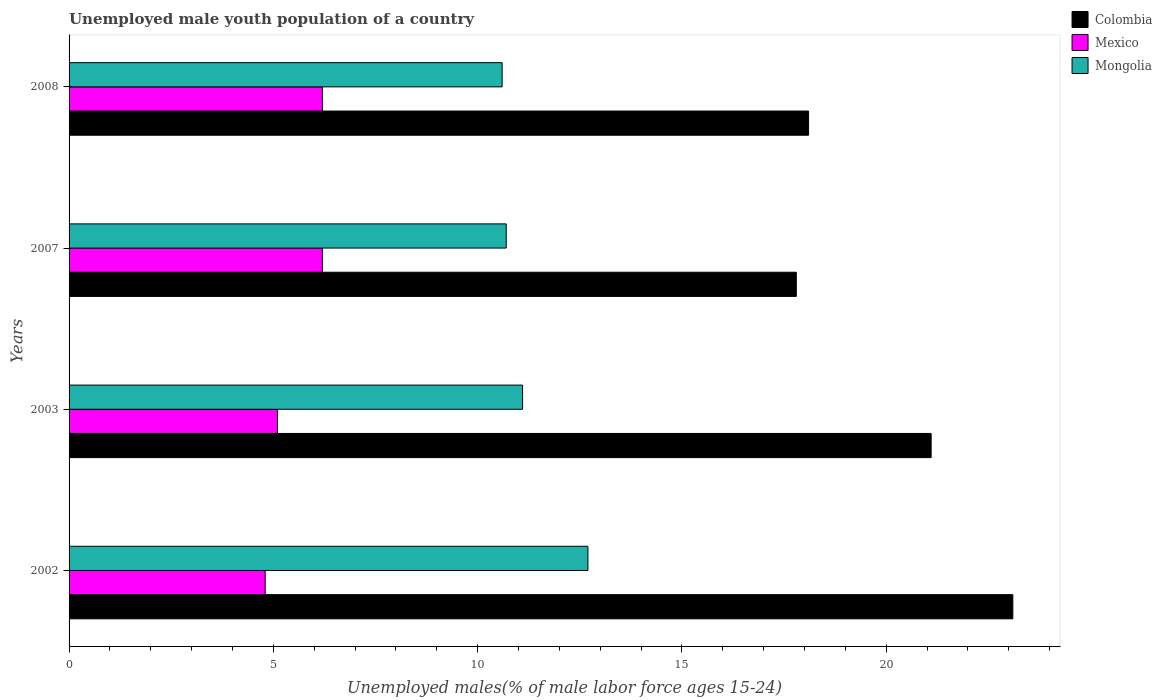Are the number of bars on each tick of the Y-axis equal?
Offer a terse response. Yes. How many bars are there on the 1st tick from the bottom?
Provide a succinct answer. 3. What is the percentage of unemployed male youth population in Mexico in 2008?
Offer a terse response. 6.2. Across all years, what is the maximum percentage of unemployed male youth population in Colombia?
Make the answer very short. 23.1. Across all years, what is the minimum percentage of unemployed male youth population in Colombia?
Ensure brevity in your answer.  17.8. In which year was the percentage of unemployed male youth population in Mongolia maximum?
Ensure brevity in your answer.  2002. In which year was the percentage of unemployed male youth population in Mongolia minimum?
Provide a succinct answer. 2008. What is the total percentage of unemployed male youth population in Mexico in the graph?
Provide a short and direct response. 22.3. What is the difference between the percentage of unemployed male youth population in Colombia in 2007 and that in 2008?
Provide a short and direct response. -0.3. What is the difference between the percentage of unemployed male youth population in Mexico in 2008 and the percentage of unemployed male youth population in Colombia in 2007?
Offer a terse response. -11.6. What is the average percentage of unemployed male youth population in Mongolia per year?
Give a very brief answer. 11.28. In the year 2007, what is the difference between the percentage of unemployed male youth population in Mexico and percentage of unemployed male youth population in Mongolia?
Give a very brief answer. -4.5. In how many years, is the percentage of unemployed male youth population in Mongolia greater than 9 %?
Give a very brief answer. 4. What is the ratio of the percentage of unemployed male youth population in Colombia in 2003 to that in 2008?
Keep it short and to the point. 1.17. Is the percentage of unemployed male youth population in Mexico in 2003 less than that in 2008?
Give a very brief answer. Yes. Is the difference between the percentage of unemployed male youth population in Mexico in 2002 and 2007 greater than the difference between the percentage of unemployed male youth population in Mongolia in 2002 and 2007?
Make the answer very short. No. What is the difference between the highest and the second highest percentage of unemployed male youth population in Colombia?
Offer a terse response. 2. What is the difference between the highest and the lowest percentage of unemployed male youth population in Mongolia?
Provide a succinct answer. 2.1. What does the 1st bar from the top in 2002 represents?
Give a very brief answer. Mongolia. What does the 3rd bar from the bottom in 2008 represents?
Your answer should be very brief. Mongolia. Is it the case that in every year, the sum of the percentage of unemployed male youth population in Mongolia and percentage of unemployed male youth population in Mexico is greater than the percentage of unemployed male youth population in Colombia?
Your answer should be very brief. No. How many bars are there?
Provide a short and direct response. 12. Does the graph contain any zero values?
Your answer should be very brief. No. Does the graph contain grids?
Ensure brevity in your answer.  No. How many legend labels are there?
Ensure brevity in your answer.  3. How are the legend labels stacked?
Offer a very short reply. Vertical. What is the title of the graph?
Your answer should be very brief. Unemployed male youth population of a country. Does "Brunei Darussalam" appear as one of the legend labels in the graph?
Give a very brief answer. No. What is the label or title of the X-axis?
Your answer should be compact. Unemployed males(% of male labor force ages 15-24). What is the label or title of the Y-axis?
Your response must be concise. Years. What is the Unemployed males(% of male labor force ages 15-24) in Colombia in 2002?
Offer a terse response. 23.1. What is the Unemployed males(% of male labor force ages 15-24) of Mexico in 2002?
Provide a succinct answer. 4.8. What is the Unemployed males(% of male labor force ages 15-24) in Mongolia in 2002?
Your response must be concise. 12.7. What is the Unemployed males(% of male labor force ages 15-24) in Colombia in 2003?
Your answer should be compact. 21.1. What is the Unemployed males(% of male labor force ages 15-24) in Mexico in 2003?
Make the answer very short. 5.1. What is the Unemployed males(% of male labor force ages 15-24) in Mongolia in 2003?
Provide a succinct answer. 11.1. What is the Unemployed males(% of male labor force ages 15-24) in Colombia in 2007?
Your response must be concise. 17.8. What is the Unemployed males(% of male labor force ages 15-24) of Mexico in 2007?
Provide a short and direct response. 6.2. What is the Unemployed males(% of male labor force ages 15-24) of Mongolia in 2007?
Offer a very short reply. 10.7. What is the Unemployed males(% of male labor force ages 15-24) in Colombia in 2008?
Keep it short and to the point. 18.1. What is the Unemployed males(% of male labor force ages 15-24) of Mexico in 2008?
Keep it short and to the point. 6.2. What is the Unemployed males(% of male labor force ages 15-24) of Mongolia in 2008?
Keep it short and to the point. 10.6. Across all years, what is the maximum Unemployed males(% of male labor force ages 15-24) of Colombia?
Give a very brief answer. 23.1. Across all years, what is the maximum Unemployed males(% of male labor force ages 15-24) of Mexico?
Offer a terse response. 6.2. Across all years, what is the maximum Unemployed males(% of male labor force ages 15-24) in Mongolia?
Provide a short and direct response. 12.7. Across all years, what is the minimum Unemployed males(% of male labor force ages 15-24) of Colombia?
Give a very brief answer. 17.8. Across all years, what is the minimum Unemployed males(% of male labor force ages 15-24) in Mexico?
Keep it short and to the point. 4.8. Across all years, what is the minimum Unemployed males(% of male labor force ages 15-24) of Mongolia?
Your answer should be very brief. 10.6. What is the total Unemployed males(% of male labor force ages 15-24) of Colombia in the graph?
Make the answer very short. 80.1. What is the total Unemployed males(% of male labor force ages 15-24) in Mexico in the graph?
Your answer should be very brief. 22.3. What is the total Unemployed males(% of male labor force ages 15-24) in Mongolia in the graph?
Your answer should be compact. 45.1. What is the difference between the Unemployed males(% of male labor force ages 15-24) in Mexico in 2002 and that in 2003?
Your answer should be very brief. -0.3. What is the difference between the Unemployed males(% of male labor force ages 15-24) in Mongolia in 2002 and that in 2003?
Ensure brevity in your answer.  1.6. What is the difference between the Unemployed males(% of male labor force ages 15-24) in Colombia in 2002 and that in 2008?
Offer a terse response. 5. What is the difference between the Unemployed males(% of male labor force ages 15-24) of Mexico in 2002 and that in 2008?
Make the answer very short. -1.4. What is the difference between the Unemployed males(% of male labor force ages 15-24) in Mongolia in 2003 and that in 2007?
Give a very brief answer. 0.4. What is the difference between the Unemployed males(% of male labor force ages 15-24) in Colombia in 2003 and that in 2008?
Provide a succinct answer. 3. What is the difference between the Unemployed males(% of male labor force ages 15-24) of Mongolia in 2003 and that in 2008?
Ensure brevity in your answer.  0.5. What is the difference between the Unemployed males(% of male labor force ages 15-24) in Mexico in 2007 and that in 2008?
Make the answer very short. 0. What is the difference between the Unemployed males(% of male labor force ages 15-24) in Mongolia in 2007 and that in 2008?
Your response must be concise. 0.1. What is the difference between the Unemployed males(% of male labor force ages 15-24) in Mexico in 2002 and the Unemployed males(% of male labor force ages 15-24) in Mongolia in 2003?
Your response must be concise. -6.3. What is the difference between the Unemployed males(% of male labor force ages 15-24) in Colombia in 2002 and the Unemployed males(% of male labor force ages 15-24) in Mexico in 2007?
Offer a very short reply. 16.9. What is the difference between the Unemployed males(% of male labor force ages 15-24) of Colombia in 2002 and the Unemployed males(% of male labor force ages 15-24) of Mongolia in 2007?
Your answer should be compact. 12.4. What is the difference between the Unemployed males(% of male labor force ages 15-24) in Mexico in 2002 and the Unemployed males(% of male labor force ages 15-24) in Mongolia in 2007?
Ensure brevity in your answer.  -5.9. What is the difference between the Unemployed males(% of male labor force ages 15-24) of Colombia in 2002 and the Unemployed males(% of male labor force ages 15-24) of Mexico in 2008?
Provide a short and direct response. 16.9. What is the difference between the Unemployed males(% of male labor force ages 15-24) in Mexico in 2003 and the Unemployed males(% of male labor force ages 15-24) in Mongolia in 2008?
Keep it short and to the point. -5.5. What is the difference between the Unemployed males(% of male labor force ages 15-24) in Colombia in 2007 and the Unemployed males(% of male labor force ages 15-24) in Mongolia in 2008?
Offer a terse response. 7.2. What is the difference between the Unemployed males(% of male labor force ages 15-24) in Mexico in 2007 and the Unemployed males(% of male labor force ages 15-24) in Mongolia in 2008?
Your response must be concise. -4.4. What is the average Unemployed males(% of male labor force ages 15-24) in Colombia per year?
Ensure brevity in your answer.  20.02. What is the average Unemployed males(% of male labor force ages 15-24) of Mexico per year?
Your response must be concise. 5.58. What is the average Unemployed males(% of male labor force ages 15-24) of Mongolia per year?
Ensure brevity in your answer.  11.28. In the year 2002, what is the difference between the Unemployed males(% of male labor force ages 15-24) in Colombia and Unemployed males(% of male labor force ages 15-24) in Mexico?
Make the answer very short. 18.3. In the year 2002, what is the difference between the Unemployed males(% of male labor force ages 15-24) of Colombia and Unemployed males(% of male labor force ages 15-24) of Mongolia?
Make the answer very short. 10.4. In the year 2003, what is the difference between the Unemployed males(% of male labor force ages 15-24) in Colombia and Unemployed males(% of male labor force ages 15-24) in Mongolia?
Your answer should be very brief. 10. In the year 2003, what is the difference between the Unemployed males(% of male labor force ages 15-24) in Mexico and Unemployed males(% of male labor force ages 15-24) in Mongolia?
Offer a terse response. -6. In the year 2007, what is the difference between the Unemployed males(% of male labor force ages 15-24) in Colombia and Unemployed males(% of male labor force ages 15-24) in Mexico?
Provide a short and direct response. 11.6. In the year 2007, what is the difference between the Unemployed males(% of male labor force ages 15-24) in Colombia and Unemployed males(% of male labor force ages 15-24) in Mongolia?
Your response must be concise. 7.1. In the year 2007, what is the difference between the Unemployed males(% of male labor force ages 15-24) in Mexico and Unemployed males(% of male labor force ages 15-24) in Mongolia?
Your response must be concise. -4.5. In the year 2008, what is the difference between the Unemployed males(% of male labor force ages 15-24) of Mexico and Unemployed males(% of male labor force ages 15-24) of Mongolia?
Your answer should be very brief. -4.4. What is the ratio of the Unemployed males(% of male labor force ages 15-24) of Colombia in 2002 to that in 2003?
Ensure brevity in your answer.  1.09. What is the ratio of the Unemployed males(% of male labor force ages 15-24) of Mexico in 2002 to that in 2003?
Offer a terse response. 0.94. What is the ratio of the Unemployed males(% of male labor force ages 15-24) in Mongolia in 2002 to that in 2003?
Provide a succinct answer. 1.14. What is the ratio of the Unemployed males(% of male labor force ages 15-24) of Colombia in 2002 to that in 2007?
Make the answer very short. 1.3. What is the ratio of the Unemployed males(% of male labor force ages 15-24) of Mexico in 2002 to that in 2007?
Offer a very short reply. 0.77. What is the ratio of the Unemployed males(% of male labor force ages 15-24) of Mongolia in 2002 to that in 2007?
Ensure brevity in your answer.  1.19. What is the ratio of the Unemployed males(% of male labor force ages 15-24) in Colombia in 2002 to that in 2008?
Provide a short and direct response. 1.28. What is the ratio of the Unemployed males(% of male labor force ages 15-24) of Mexico in 2002 to that in 2008?
Your answer should be very brief. 0.77. What is the ratio of the Unemployed males(% of male labor force ages 15-24) in Mongolia in 2002 to that in 2008?
Provide a short and direct response. 1.2. What is the ratio of the Unemployed males(% of male labor force ages 15-24) of Colombia in 2003 to that in 2007?
Your answer should be compact. 1.19. What is the ratio of the Unemployed males(% of male labor force ages 15-24) in Mexico in 2003 to that in 2007?
Provide a short and direct response. 0.82. What is the ratio of the Unemployed males(% of male labor force ages 15-24) of Mongolia in 2003 to that in 2007?
Your answer should be compact. 1.04. What is the ratio of the Unemployed males(% of male labor force ages 15-24) of Colombia in 2003 to that in 2008?
Ensure brevity in your answer.  1.17. What is the ratio of the Unemployed males(% of male labor force ages 15-24) in Mexico in 2003 to that in 2008?
Provide a succinct answer. 0.82. What is the ratio of the Unemployed males(% of male labor force ages 15-24) in Mongolia in 2003 to that in 2008?
Provide a short and direct response. 1.05. What is the ratio of the Unemployed males(% of male labor force ages 15-24) of Colombia in 2007 to that in 2008?
Ensure brevity in your answer.  0.98. What is the ratio of the Unemployed males(% of male labor force ages 15-24) of Mexico in 2007 to that in 2008?
Offer a terse response. 1. What is the ratio of the Unemployed males(% of male labor force ages 15-24) of Mongolia in 2007 to that in 2008?
Make the answer very short. 1.01. What is the difference between the highest and the second highest Unemployed males(% of male labor force ages 15-24) in Colombia?
Provide a short and direct response. 2. What is the difference between the highest and the second highest Unemployed males(% of male labor force ages 15-24) in Mongolia?
Your response must be concise. 1.6. What is the difference between the highest and the lowest Unemployed males(% of male labor force ages 15-24) in Mongolia?
Offer a very short reply. 2.1. 